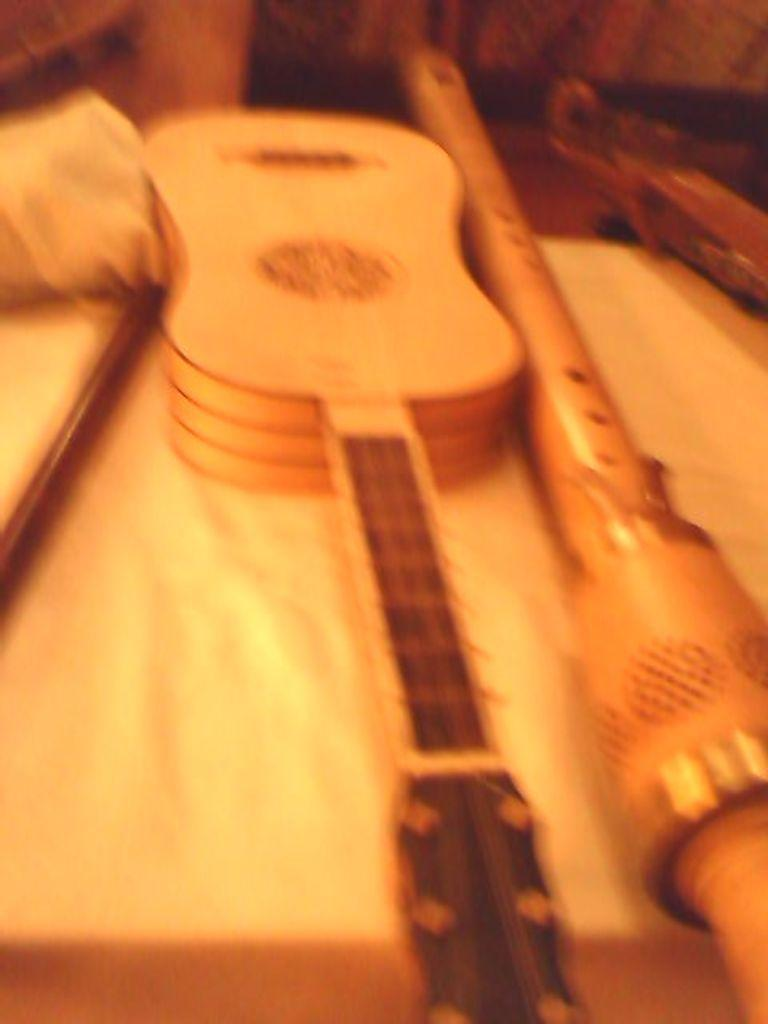What musical instrument is visible in the image? There is a guitar in the image. What else can be seen on the table in the image? There are other objects on the table in the image, but their specific details are not provided. How much water is flowing in the stream in the image? There is no stream present in the image; it only features a guitar and other objects on a table. 